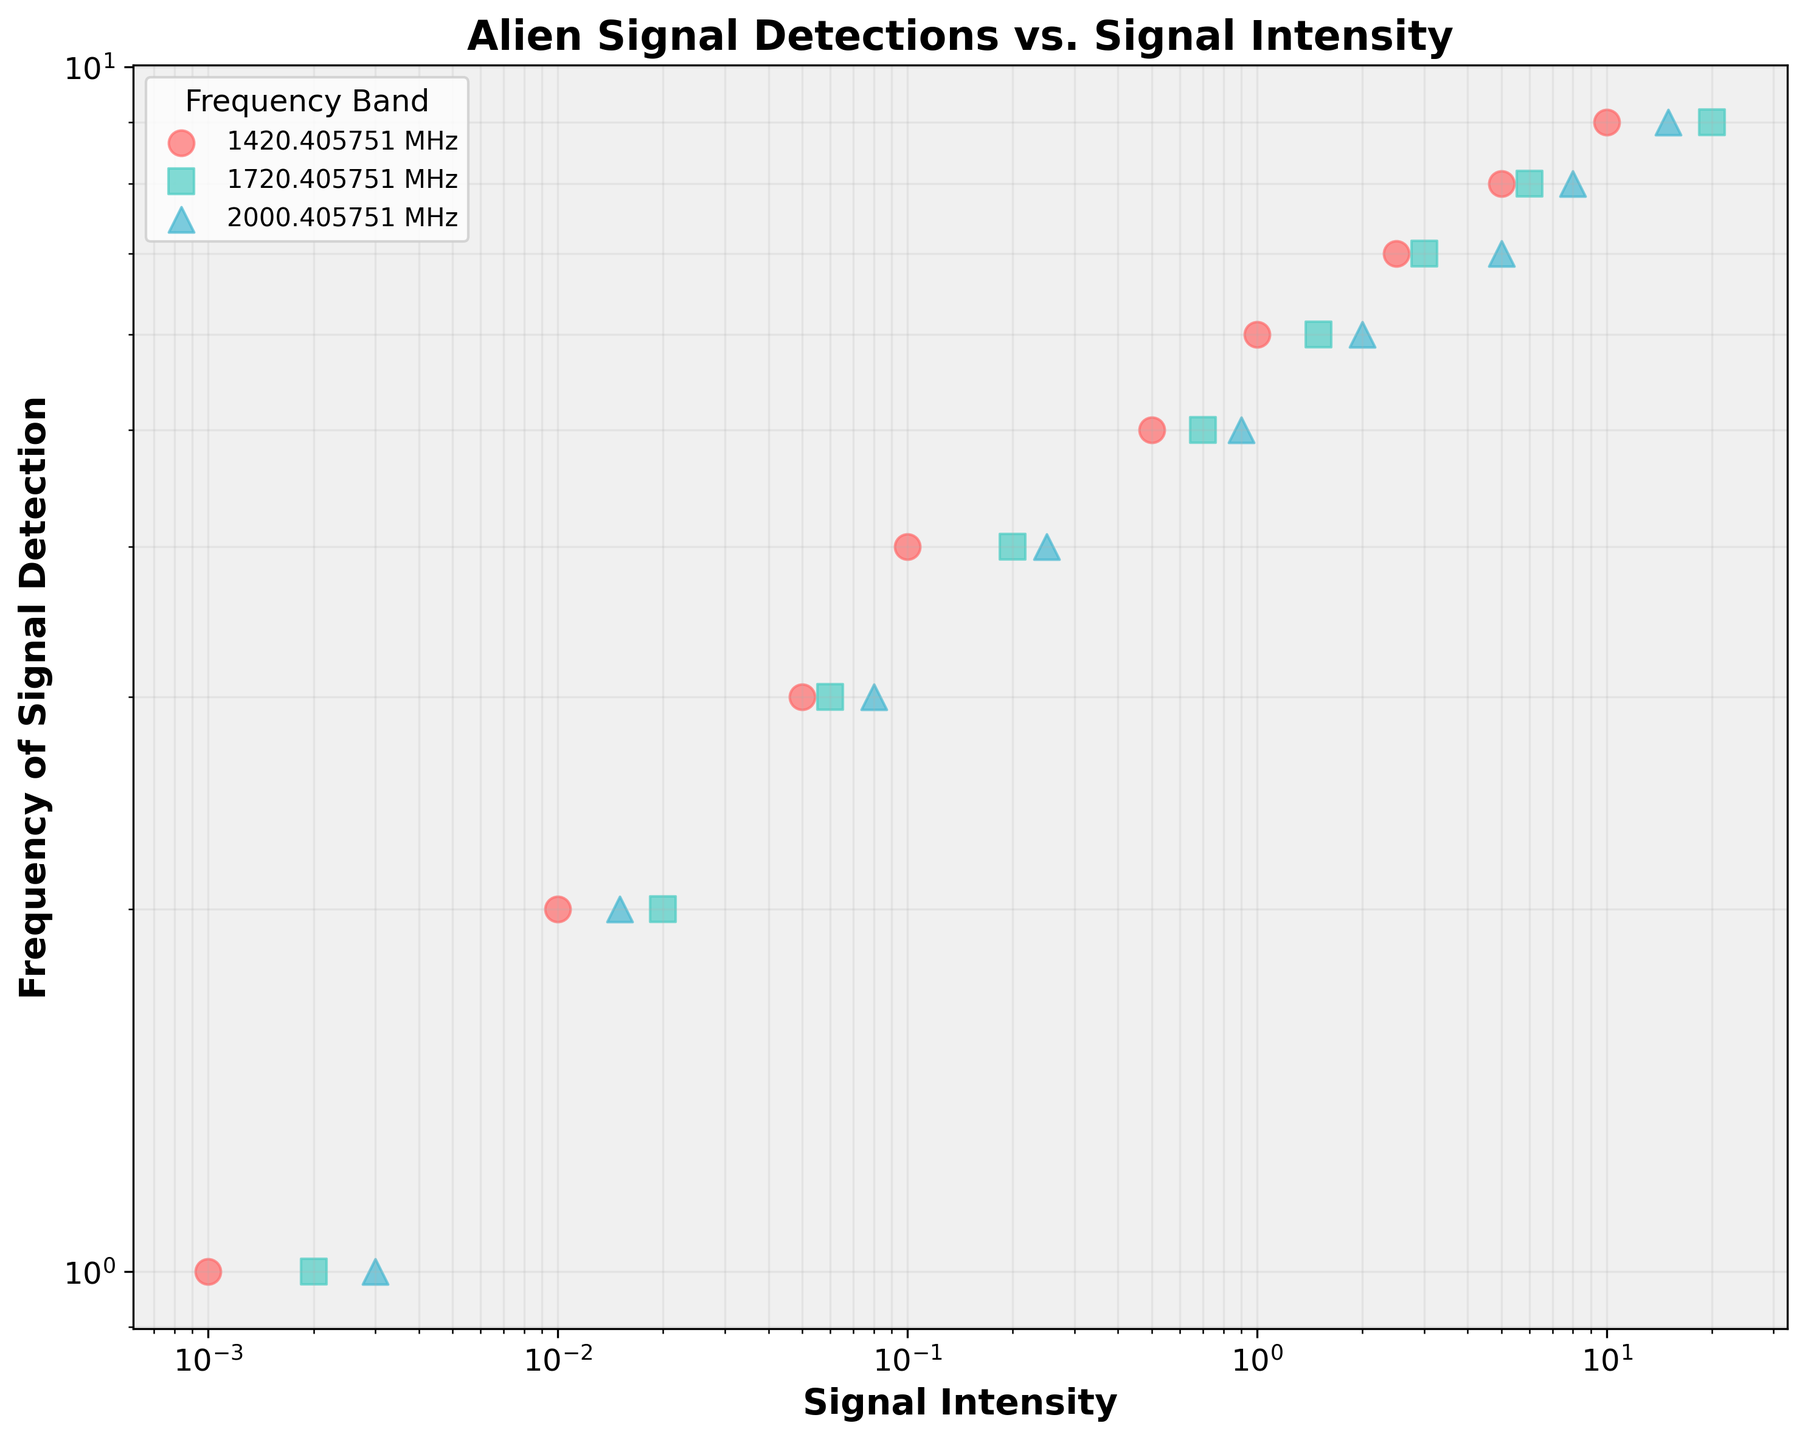Which frequency band has the highest signal intensity detected? The highest signal intensity detected appears to be 20.0, which is in the 1720.405751 MHz frequency band as indicated by the data points and legend.
Answer: 1720.405751 MHz How many frequency bands are represented in the plot? The legend of the plot shows distinct markers for each frequency band, and there are three unique markers representing three frequency bands.
Answer: 3 What is the signal intensity for the first signal detection in the 1420.405751 MHz frequency band? The first signal detection in the 1420.405751 MHz frequency band has a signal intensity of 0.001, as shown by the first data point in the corresponding series.
Answer: 0.001 Which frequency band shows the steepest increase in signal intensity with increasing signal detection frequency? By visually inspecting the scatter plot, the 1720.405751 MHz frequency band shows a steep increase in signal intensity as the frequency of signal detection increases compared to the other bands.
Answer: 1720.405751 MHz Are there any frequency bands where the signal intensity starts below 0.01? Yes, the 1420.405751 MHz and 1720.405751 MHz frequency bands both have signal intensities starting below 0.01 as indicated by their first data points.
Answer: Yes Which frequency band has the lowest starting signal intensity? The 1420.405751 MHz frequency band has the lowest starting signal intensity of 0.001, which is less than the starting intensities of the other frequency bands.
Answer: 1420.405751 MHz At which signal intensity do we observe the 6th signal detection event in the 2000.405751 MHz frequency band? The 6th signal detection event in the 2000.405751 MHz frequency band has a signal intensity of 2.0, which can be read off from the plot.
Answer: 2.0 How does the signal intensity for the 9th signal detection compare across all frequency bands? For the 9th signal detection, the signal intensity is 10.0 for 1420.405751 MHz, 20.0 for 1720.405751 MHz, and 15.0 for 2000.405751 MHz. The 1720.405751 MHz band has the highest value while 1420.405751 MHz has the lowest.
Answer: 1420.405751 MHz: 10.0, 1720.405751 MHz: 20.0, 2000.405751 MHz: 15.0 What is the general trend in signal intensity as the frequency of signal detection increases? Across all frequency bands, there is a trend where the signal intensity generally increases as the frequency of signal detection increases, which is evident from the ascending scatter points in each series.
Answer: Signal intensity increases 